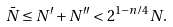<formula> <loc_0><loc_0><loc_500><loc_500>\bar { N } \leq N ^ { \prime } + N ^ { \prime \prime } < 2 ^ { 1 - n / 4 } N .</formula> 